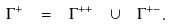<formula> <loc_0><loc_0><loc_500><loc_500>\Gamma ^ { + } \ = \ \Gamma ^ { + + } \ \cup \ \Gamma ^ { + - } .</formula> 